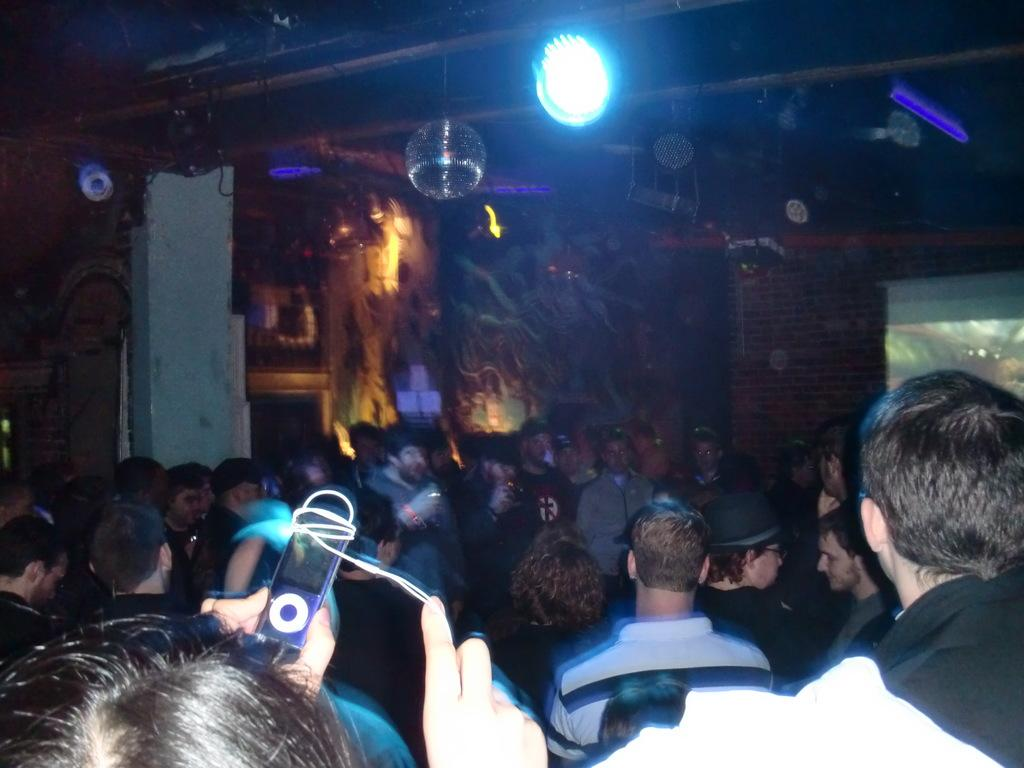How many people are in the image? There are many persons in the image. What device is located in the middle of the image? There is an iPod in the middle of the image. What can be seen at the top of the image? There are lights at the top of the image. What type of card is being used to start the iPod in the image? There is no card present in the image, and the iPod does not require a card to start. 